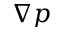<formula> <loc_0><loc_0><loc_500><loc_500>\nabla p</formula> 